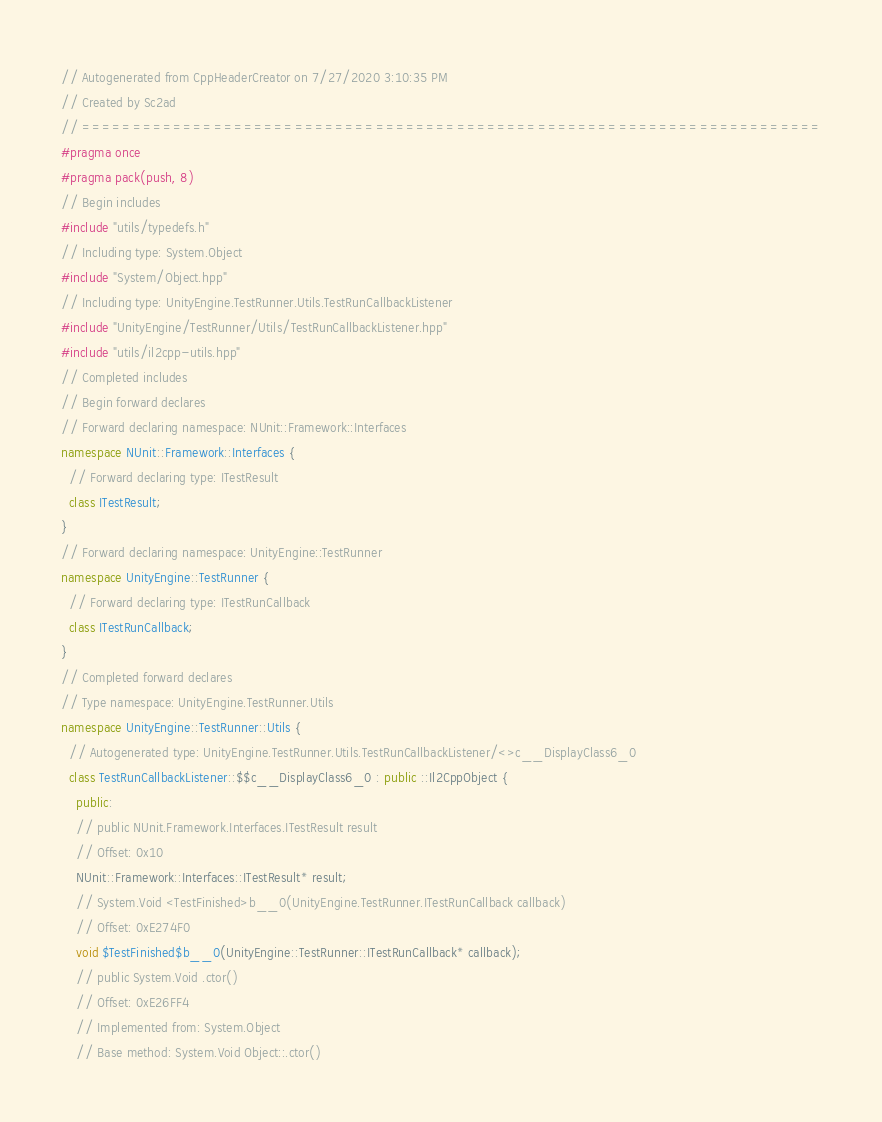Convert code to text. <code><loc_0><loc_0><loc_500><loc_500><_C++_>// Autogenerated from CppHeaderCreator on 7/27/2020 3:10:35 PM
// Created by Sc2ad
// =========================================================================
#pragma once
#pragma pack(push, 8)
// Begin includes
#include "utils/typedefs.h"
// Including type: System.Object
#include "System/Object.hpp"
// Including type: UnityEngine.TestRunner.Utils.TestRunCallbackListener
#include "UnityEngine/TestRunner/Utils/TestRunCallbackListener.hpp"
#include "utils/il2cpp-utils.hpp"
// Completed includes
// Begin forward declares
// Forward declaring namespace: NUnit::Framework::Interfaces
namespace NUnit::Framework::Interfaces {
  // Forward declaring type: ITestResult
  class ITestResult;
}
// Forward declaring namespace: UnityEngine::TestRunner
namespace UnityEngine::TestRunner {
  // Forward declaring type: ITestRunCallback
  class ITestRunCallback;
}
// Completed forward declares
// Type namespace: UnityEngine.TestRunner.Utils
namespace UnityEngine::TestRunner::Utils {
  // Autogenerated type: UnityEngine.TestRunner.Utils.TestRunCallbackListener/<>c__DisplayClass6_0
  class TestRunCallbackListener::$$c__DisplayClass6_0 : public ::Il2CppObject {
    public:
    // public NUnit.Framework.Interfaces.ITestResult result
    // Offset: 0x10
    NUnit::Framework::Interfaces::ITestResult* result;
    // System.Void <TestFinished>b__0(UnityEngine.TestRunner.ITestRunCallback callback)
    // Offset: 0xE274F0
    void $TestFinished$b__0(UnityEngine::TestRunner::ITestRunCallback* callback);
    // public System.Void .ctor()
    // Offset: 0xE26FF4
    // Implemented from: System.Object
    // Base method: System.Void Object::.ctor()</code> 